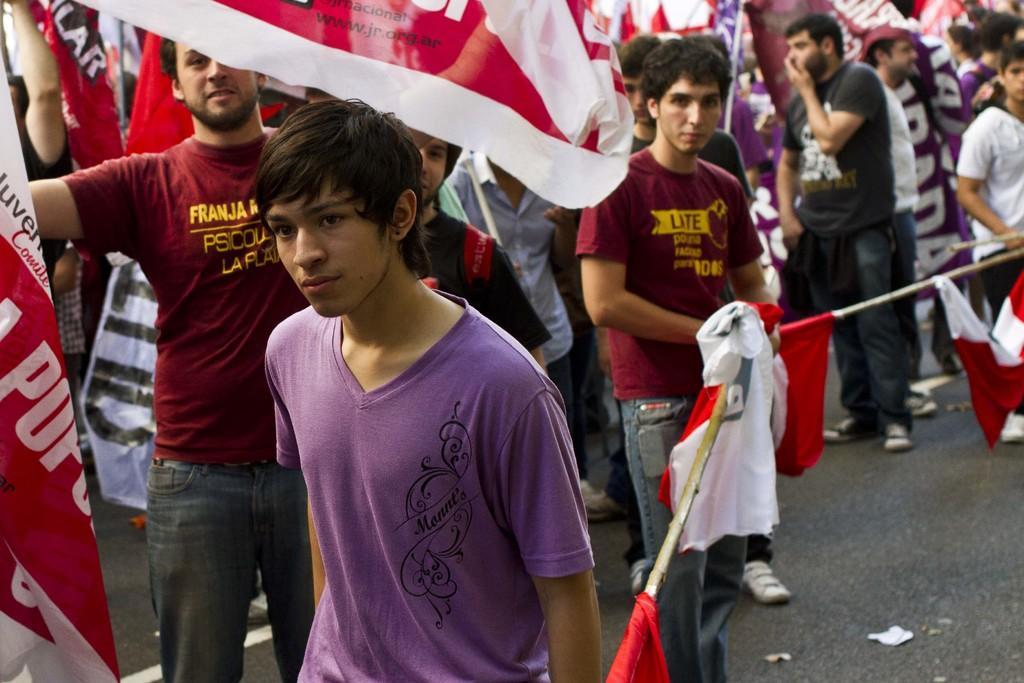Describe this image in one or two sentences. To the front of the image there is a man with violet t-shirt is standing. Behind him there are few people with maroon t-shirt is standing. They are holding the pink and white color posters in their hands. To the right of the image there is a rope and few people are holding it. To the right bottom of the image there is a road. 